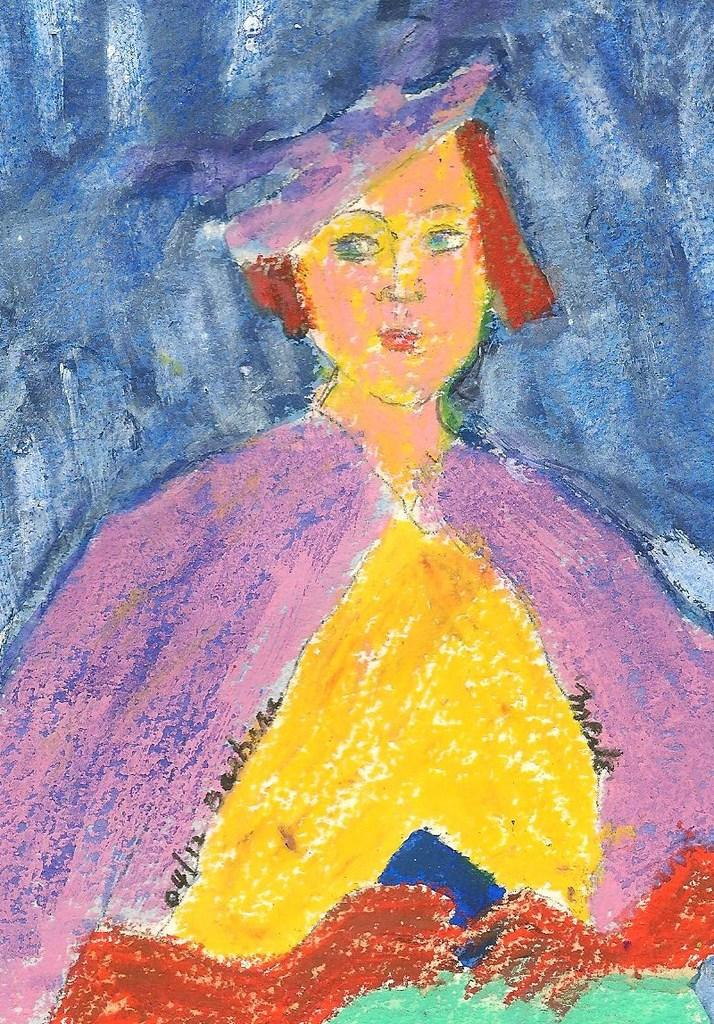What is depicted in the painting in the image? There is a painting of a lady in the image. Is there any additional information on the painting? Yes, there is a date on the painting. Are there any words or phrases on the painting? Yes, there is some text on the painting. Where is the tub located in the image? There is no tub present in the image. What type of class is being taught in the image? There is no class or teaching activity depicted in the image. 